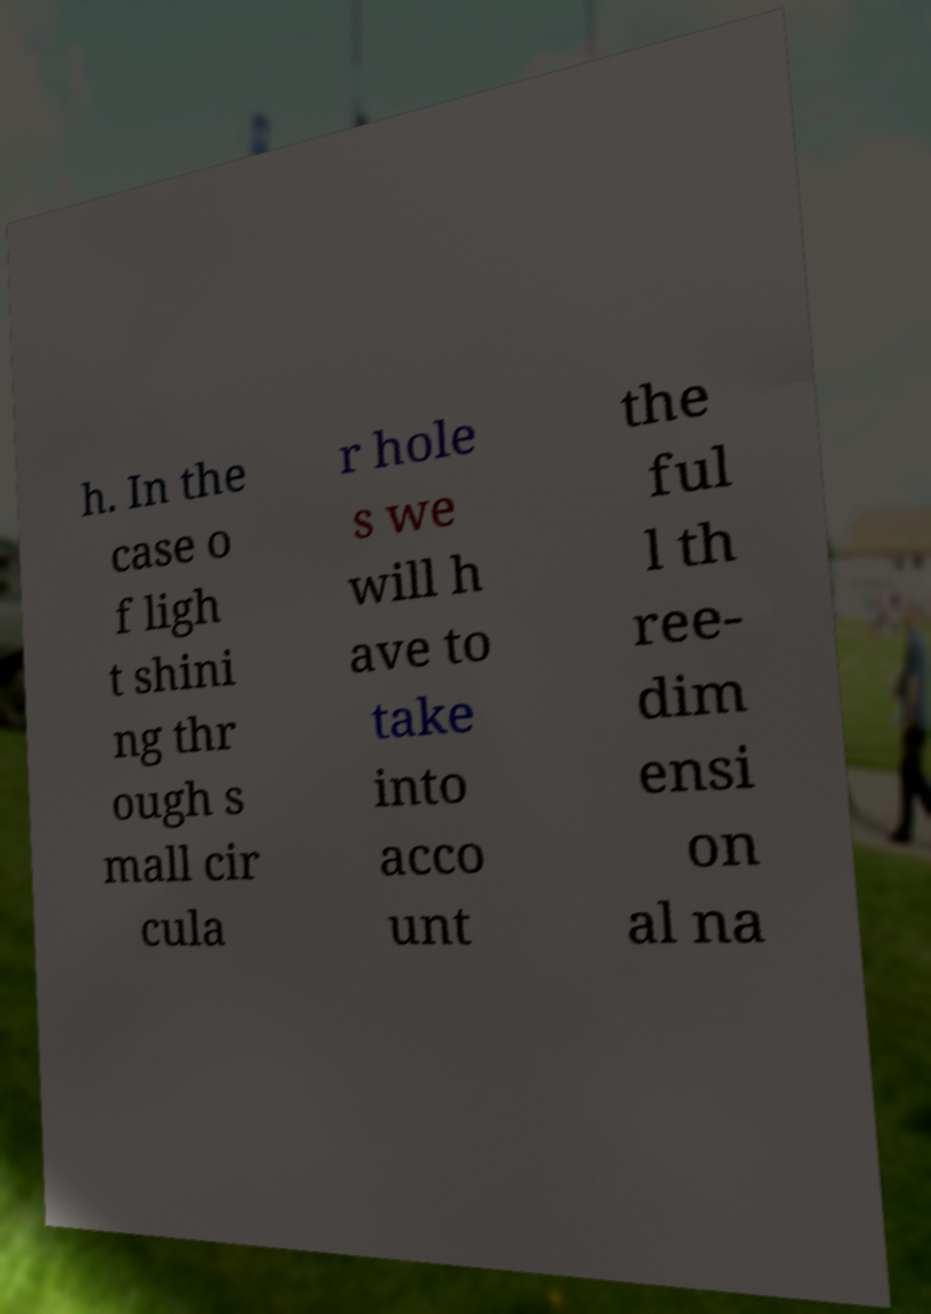I need the written content from this picture converted into text. Can you do that? h. In the case o f ligh t shini ng thr ough s mall cir cula r hole s we will h ave to take into acco unt the ful l th ree- dim ensi on al na 